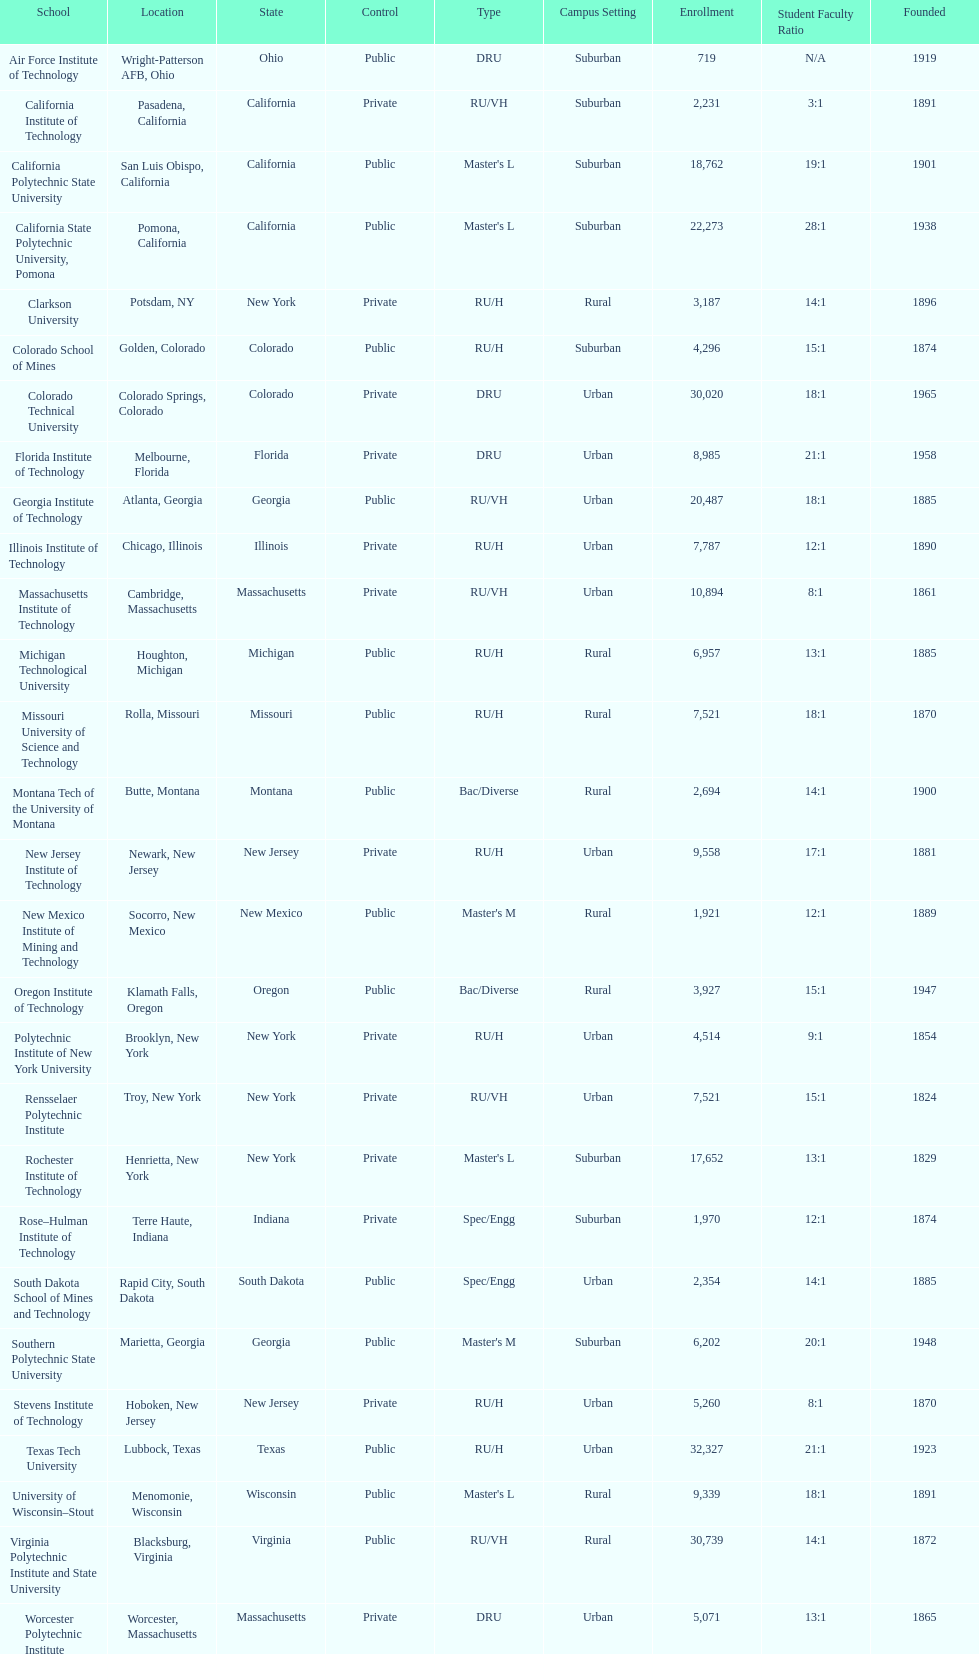What school is listed next after michigan technological university? Missouri University of Science and Technology. 